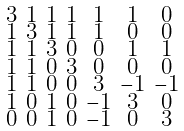<formula> <loc_0><loc_0><loc_500><loc_500>\begin{smallmatrix} 3 & 1 & 1 & 1 & 1 & 1 & 0 \\ 1 & 3 & 1 & 1 & 1 & 0 & 0 \\ 1 & 1 & 3 & 0 & 0 & 1 & 1 \\ 1 & 1 & 0 & 3 & 0 & 0 & 0 \\ 1 & 1 & 0 & 0 & 3 & - 1 & - 1 \\ 1 & 0 & 1 & 0 & - 1 & 3 & 0 \\ 0 & 0 & 1 & 0 & - 1 & 0 & 3 \end{smallmatrix}</formula> 